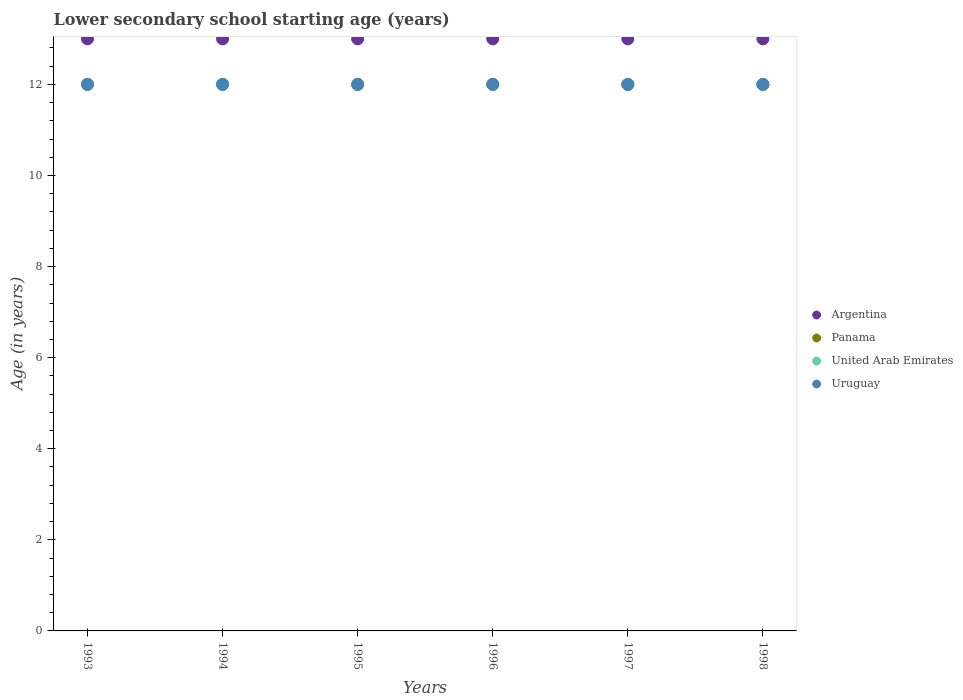Is the number of dotlines equal to the number of legend labels?
Your response must be concise. Yes. What is the lower secondary school starting age of children in Panama in 1996?
Ensure brevity in your answer.  12. Across all years, what is the maximum lower secondary school starting age of children in United Arab Emirates?
Offer a very short reply. 12. Across all years, what is the minimum lower secondary school starting age of children in Uruguay?
Keep it short and to the point. 12. In which year was the lower secondary school starting age of children in Argentina maximum?
Offer a very short reply. 1993. In which year was the lower secondary school starting age of children in Uruguay minimum?
Your answer should be compact. 1993. What is the total lower secondary school starting age of children in United Arab Emirates in the graph?
Give a very brief answer. 72. What is the difference between the lower secondary school starting age of children in Panama in 1994 and the lower secondary school starting age of children in United Arab Emirates in 1997?
Ensure brevity in your answer.  0. In the year 1996, what is the difference between the lower secondary school starting age of children in United Arab Emirates and lower secondary school starting age of children in Argentina?
Your answer should be compact. -1. In how many years, is the lower secondary school starting age of children in Argentina greater than 9.2 years?
Your answer should be compact. 6. Is the lower secondary school starting age of children in Argentina in 1994 less than that in 1998?
Your response must be concise. No. What is the difference between the highest and the second highest lower secondary school starting age of children in Argentina?
Provide a short and direct response. 0. Is it the case that in every year, the sum of the lower secondary school starting age of children in Argentina and lower secondary school starting age of children in Uruguay  is greater than the sum of lower secondary school starting age of children in United Arab Emirates and lower secondary school starting age of children in Panama?
Keep it short and to the point. No. Is it the case that in every year, the sum of the lower secondary school starting age of children in Panama and lower secondary school starting age of children in United Arab Emirates  is greater than the lower secondary school starting age of children in Argentina?
Provide a succinct answer. Yes. How many dotlines are there?
Keep it short and to the point. 4. How many years are there in the graph?
Keep it short and to the point. 6. What is the difference between two consecutive major ticks on the Y-axis?
Offer a terse response. 2. Are the values on the major ticks of Y-axis written in scientific E-notation?
Give a very brief answer. No. Where does the legend appear in the graph?
Provide a short and direct response. Center right. How are the legend labels stacked?
Offer a very short reply. Vertical. What is the title of the graph?
Keep it short and to the point. Lower secondary school starting age (years). Does "Middle East & North Africa (developing only)" appear as one of the legend labels in the graph?
Keep it short and to the point. No. What is the label or title of the X-axis?
Provide a short and direct response. Years. What is the label or title of the Y-axis?
Offer a terse response. Age (in years). What is the Age (in years) of United Arab Emirates in 1993?
Give a very brief answer. 12. What is the Age (in years) of Uruguay in 1993?
Provide a short and direct response. 12. What is the Age (in years) of Argentina in 1994?
Provide a succinct answer. 13. What is the Age (in years) in United Arab Emirates in 1994?
Your response must be concise. 12. What is the Age (in years) of Argentina in 1995?
Your answer should be very brief. 13. What is the Age (in years) of Panama in 1995?
Make the answer very short. 12. What is the Age (in years) of United Arab Emirates in 1995?
Your answer should be compact. 12. What is the Age (in years) in Argentina in 1996?
Offer a terse response. 13. What is the Age (in years) of Panama in 1996?
Your answer should be very brief. 12. What is the Age (in years) in United Arab Emirates in 1996?
Ensure brevity in your answer.  12. What is the Age (in years) in Uruguay in 1996?
Keep it short and to the point. 12. What is the Age (in years) of Argentina in 1998?
Your answer should be compact. 13. What is the Age (in years) in Uruguay in 1998?
Keep it short and to the point. 12. Across all years, what is the maximum Age (in years) in Argentina?
Your answer should be very brief. 13. Across all years, what is the maximum Age (in years) in Uruguay?
Your answer should be compact. 12. Across all years, what is the minimum Age (in years) of Panama?
Ensure brevity in your answer.  12. Across all years, what is the minimum Age (in years) of United Arab Emirates?
Provide a short and direct response. 12. What is the total Age (in years) of Argentina in the graph?
Make the answer very short. 78. What is the total Age (in years) in Panama in the graph?
Provide a succinct answer. 72. What is the difference between the Age (in years) of Argentina in 1993 and that in 1994?
Provide a short and direct response. 0. What is the difference between the Age (in years) of United Arab Emirates in 1993 and that in 1994?
Keep it short and to the point. 0. What is the difference between the Age (in years) in Uruguay in 1993 and that in 1995?
Your answer should be very brief. 0. What is the difference between the Age (in years) in United Arab Emirates in 1993 and that in 1996?
Make the answer very short. 0. What is the difference between the Age (in years) in United Arab Emirates in 1993 and that in 1997?
Offer a very short reply. 0. What is the difference between the Age (in years) of Uruguay in 1993 and that in 1997?
Keep it short and to the point. 0. What is the difference between the Age (in years) in Argentina in 1993 and that in 1998?
Give a very brief answer. 0. What is the difference between the Age (in years) in Panama in 1993 and that in 1998?
Make the answer very short. 0. What is the difference between the Age (in years) of United Arab Emirates in 1993 and that in 1998?
Your answer should be very brief. 0. What is the difference between the Age (in years) in Uruguay in 1993 and that in 1998?
Offer a very short reply. 0. What is the difference between the Age (in years) of Argentina in 1994 and that in 1995?
Offer a terse response. 0. What is the difference between the Age (in years) of United Arab Emirates in 1994 and that in 1995?
Your answer should be compact. 0. What is the difference between the Age (in years) of Panama in 1994 and that in 1996?
Give a very brief answer. 0. What is the difference between the Age (in years) of United Arab Emirates in 1994 and that in 1997?
Give a very brief answer. 0. What is the difference between the Age (in years) of Panama in 1994 and that in 1998?
Give a very brief answer. 0. What is the difference between the Age (in years) in Argentina in 1995 and that in 1996?
Keep it short and to the point. 0. What is the difference between the Age (in years) of Panama in 1995 and that in 1996?
Offer a terse response. 0. What is the difference between the Age (in years) in United Arab Emirates in 1995 and that in 1996?
Provide a short and direct response. 0. What is the difference between the Age (in years) of Argentina in 1995 and that in 1997?
Your response must be concise. 0. What is the difference between the Age (in years) of Panama in 1995 and that in 1997?
Provide a succinct answer. 0. What is the difference between the Age (in years) of United Arab Emirates in 1995 and that in 1997?
Your response must be concise. 0. What is the difference between the Age (in years) in Uruguay in 1995 and that in 1997?
Offer a very short reply. 0. What is the difference between the Age (in years) of United Arab Emirates in 1996 and that in 1997?
Ensure brevity in your answer.  0. What is the difference between the Age (in years) of Argentina in 1997 and that in 1998?
Provide a succinct answer. 0. What is the difference between the Age (in years) of Panama in 1997 and that in 1998?
Offer a very short reply. 0. What is the difference between the Age (in years) in Uruguay in 1997 and that in 1998?
Make the answer very short. 0. What is the difference between the Age (in years) in Argentina in 1993 and the Age (in years) in Uruguay in 1994?
Offer a very short reply. 1. What is the difference between the Age (in years) of Panama in 1993 and the Age (in years) of Uruguay in 1994?
Offer a very short reply. 0. What is the difference between the Age (in years) in United Arab Emirates in 1993 and the Age (in years) in Uruguay in 1994?
Your response must be concise. 0. What is the difference between the Age (in years) of Argentina in 1993 and the Age (in years) of Uruguay in 1995?
Offer a very short reply. 1. What is the difference between the Age (in years) in Panama in 1993 and the Age (in years) in United Arab Emirates in 1995?
Your answer should be very brief. 0. What is the difference between the Age (in years) of Panama in 1993 and the Age (in years) of Uruguay in 1995?
Your response must be concise. 0. What is the difference between the Age (in years) in United Arab Emirates in 1993 and the Age (in years) in Uruguay in 1995?
Ensure brevity in your answer.  0. What is the difference between the Age (in years) in Argentina in 1993 and the Age (in years) in Panama in 1996?
Your response must be concise. 1. What is the difference between the Age (in years) in Panama in 1993 and the Age (in years) in United Arab Emirates in 1996?
Your response must be concise. 0. What is the difference between the Age (in years) of United Arab Emirates in 1993 and the Age (in years) of Uruguay in 1996?
Provide a short and direct response. 0. What is the difference between the Age (in years) in Argentina in 1993 and the Age (in years) in Panama in 1997?
Keep it short and to the point. 1. What is the difference between the Age (in years) in Argentina in 1993 and the Age (in years) in Uruguay in 1997?
Your response must be concise. 1. What is the difference between the Age (in years) in Panama in 1993 and the Age (in years) in United Arab Emirates in 1997?
Provide a short and direct response. 0. What is the difference between the Age (in years) of Panama in 1993 and the Age (in years) of Uruguay in 1997?
Give a very brief answer. 0. What is the difference between the Age (in years) in Argentina in 1993 and the Age (in years) in Panama in 1998?
Your response must be concise. 1. What is the difference between the Age (in years) in Argentina in 1993 and the Age (in years) in Uruguay in 1998?
Keep it short and to the point. 1. What is the difference between the Age (in years) of Panama in 1993 and the Age (in years) of United Arab Emirates in 1998?
Ensure brevity in your answer.  0. What is the difference between the Age (in years) in Panama in 1993 and the Age (in years) in Uruguay in 1998?
Your answer should be compact. 0. What is the difference between the Age (in years) of Argentina in 1994 and the Age (in years) of Panama in 1995?
Make the answer very short. 1. What is the difference between the Age (in years) in Argentina in 1994 and the Age (in years) in Uruguay in 1995?
Your answer should be compact. 1. What is the difference between the Age (in years) of Argentina in 1994 and the Age (in years) of United Arab Emirates in 1996?
Make the answer very short. 1. What is the difference between the Age (in years) of Argentina in 1994 and the Age (in years) of Uruguay in 1996?
Ensure brevity in your answer.  1. What is the difference between the Age (in years) in Argentina in 1994 and the Age (in years) in United Arab Emirates in 1997?
Your answer should be very brief. 1. What is the difference between the Age (in years) of Panama in 1994 and the Age (in years) of United Arab Emirates in 1997?
Offer a very short reply. 0. What is the difference between the Age (in years) in United Arab Emirates in 1994 and the Age (in years) in Uruguay in 1997?
Ensure brevity in your answer.  0. What is the difference between the Age (in years) in Argentina in 1994 and the Age (in years) in Panama in 1998?
Keep it short and to the point. 1. What is the difference between the Age (in years) in Argentina in 1994 and the Age (in years) in United Arab Emirates in 1998?
Ensure brevity in your answer.  1. What is the difference between the Age (in years) in Argentina in 1994 and the Age (in years) in Uruguay in 1998?
Your response must be concise. 1. What is the difference between the Age (in years) in Panama in 1994 and the Age (in years) in United Arab Emirates in 1998?
Provide a short and direct response. 0. What is the difference between the Age (in years) of Argentina in 1995 and the Age (in years) of Panama in 1996?
Offer a terse response. 1. What is the difference between the Age (in years) of Argentina in 1995 and the Age (in years) of United Arab Emirates in 1996?
Keep it short and to the point. 1. What is the difference between the Age (in years) in United Arab Emirates in 1995 and the Age (in years) in Uruguay in 1996?
Your answer should be very brief. 0. What is the difference between the Age (in years) of Argentina in 1995 and the Age (in years) of Uruguay in 1997?
Ensure brevity in your answer.  1. What is the difference between the Age (in years) in Panama in 1995 and the Age (in years) in Uruguay in 1997?
Your response must be concise. 0. What is the difference between the Age (in years) of Argentina in 1995 and the Age (in years) of Panama in 1998?
Make the answer very short. 1. What is the difference between the Age (in years) of Argentina in 1995 and the Age (in years) of United Arab Emirates in 1998?
Provide a short and direct response. 1. What is the difference between the Age (in years) of United Arab Emirates in 1995 and the Age (in years) of Uruguay in 1998?
Offer a very short reply. 0. What is the difference between the Age (in years) in Argentina in 1996 and the Age (in years) in Panama in 1997?
Offer a very short reply. 1. What is the difference between the Age (in years) of Argentina in 1996 and the Age (in years) of United Arab Emirates in 1997?
Provide a succinct answer. 1. What is the difference between the Age (in years) in Panama in 1996 and the Age (in years) in Uruguay in 1997?
Provide a succinct answer. 0. What is the difference between the Age (in years) in United Arab Emirates in 1996 and the Age (in years) in Uruguay in 1997?
Make the answer very short. 0. What is the difference between the Age (in years) of Panama in 1996 and the Age (in years) of United Arab Emirates in 1998?
Keep it short and to the point. 0. What is the difference between the Age (in years) of Panama in 1996 and the Age (in years) of Uruguay in 1998?
Ensure brevity in your answer.  0. What is the difference between the Age (in years) of United Arab Emirates in 1996 and the Age (in years) of Uruguay in 1998?
Your response must be concise. 0. What is the difference between the Age (in years) in Argentina in 1997 and the Age (in years) in Panama in 1998?
Give a very brief answer. 1. What is the difference between the Age (in years) in United Arab Emirates in 1997 and the Age (in years) in Uruguay in 1998?
Offer a terse response. 0. What is the average Age (in years) in Argentina per year?
Your answer should be compact. 13. What is the average Age (in years) of Panama per year?
Your response must be concise. 12. What is the average Age (in years) in United Arab Emirates per year?
Provide a short and direct response. 12. In the year 1993, what is the difference between the Age (in years) of Argentina and Age (in years) of Panama?
Give a very brief answer. 1. In the year 1994, what is the difference between the Age (in years) in Argentina and Age (in years) in United Arab Emirates?
Your answer should be very brief. 1. In the year 1994, what is the difference between the Age (in years) in Panama and Age (in years) in Uruguay?
Keep it short and to the point. 0. In the year 1994, what is the difference between the Age (in years) of United Arab Emirates and Age (in years) of Uruguay?
Your answer should be very brief. 0. In the year 1995, what is the difference between the Age (in years) of Argentina and Age (in years) of Panama?
Keep it short and to the point. 1. In the year 1995, what is the difference between the Age (in years) in Argentina and Age (in years) in Uruguay?
Provide a short and direct response. 1. In the year 1995, what is the difference between the Age (in years) in Panama and Age (in years) in United Arab Emirates?
Your answer should be very brief. 0. In the year 1996, what is the difference between the Age (in years) of Argentina and Age (in years) of Panama?
Provide a short and direct response. 1. In the year 1996, what is the difference between the Age (in years) of Panama and Age (in years) of United Arab Emirates?
Offer a very short reply. 0. In the year 1996, what is the difference between the Age (in years) in United Arab Emirates and Age (in years) in Uruguay?
Ensure brevity in your answer.  0. In the year 1997, what is the difference between the Age (in years) in Argentina and Age (in years) in United Arab Emirates?
Your answer should be very brief. 1. In the year 1998, what is the difference between the Age (in years) of Argentina and Age (in years) of United Arab Emirates?
Your answer should be very brief. 1. In the year 1998, what is the difference between the Age (in years) of Argentina and Age (in years) of Uruguay?
Ensure brevity in your answer.  1. In the year 1998, what is the difference between the Age (in years) of Panama and Age (in years) of United Arab Emirates?
Provide a succinct answer. 0. In the year 1998, what is the difference between the Age (in years) in Panama and Age (in years) in Uruguay?
Provide a succinct answer. 0. In the year 1998, what is the difference between the Age (in years) in United Arab Emirates and Age (in years) in Uruguay?
Ensure brevity in your answer.  0. What is the ratio of the Age (in years) of Argentina in 1993 to that in 1994?
Make the answer very short. 1. What is the ratio of the Age (in years) of United Arab Emirates in 1993 to that in 1994?
Offer a very short reply. 1. What is the ratio of the Age (in years) in Uruguay in 1993 to that in 1995?
Offer a terse response. 1. What is the ratio of the Age (in years) in Panama in 1993 to that in 1996?
Your answer should be compact. 1. What is the ratio of the Age (in years) of United Arab Emirates in 1993 to that in 1996?
Make the answer very short. 1. What is the ratio of the Age (in years) in Uruguay in 1993 to that in 1996?
Provide a short and direct response. 1. What is the ratio of the Age (in years) of United Arab Emirates in 1993 to that in 1997?
Provide a short and direct response. 1. What is the ratio of the Age (in years) of Uruguay in 1993 to that in 1997?
Give a very brief answer. 1. What is the ratio of the Age (in years) in Argentina in 1993 to that in 1998?
Provide a short and direct response. 1. What is the ratio of the Age (in years) of Panama in 1993 to that in 1998?
Offer a terse response. 1. What is the ratio of the Age (in years) in Argentina in 1994 to that in 1995?
Offer a very short reply. 1. What is the ratio of the Age (in years) in United Arab Emirates in 1994 to that in 1995?
Provide a short and direct response. 1. What is the ratio of the Age (in years) of Uruguay in 1994 to that in 1995?
Provide a succinct answer. 1. What is the ratio of the Age (in years) of Argentina in 1994 to that in 1996?
Your answer should be very brief. 1. What is the ratio of the Age (in years) of United Arab Emirates in 1994 to that in 1996?
Ensure brevity in your answer.  1. What is the ratio of the Age (in years) of Uruguay in 1994 to that in 1996?
Your answer should be very brief. 1. What is the ratio of the Age (in years) in Argentina in 1994 to that in 1997?
Your answer should be very brief. 1. What is the ratio of the Age (in years) in Panama in 1994 to that in 1998?
Make the answer very short. 1. What is the ratio of the Age (in years) in Uruguay in 1994 to that in 1998?
Provide a short and direct response. 1. What is the ratio of the Age (in years) in Argentina in 1995 to that in 1996?
Your response must be concise. 1. What is the ratio of the Age (in years) of Argentina in 1995 to that in 1997?
Keep it short and to the point. 1. What is the ratio of the Age (in years) in Argentina in 1995 to that in 1998?
Your answer should be very brief. 1. What is the ratio of the Age (in years) in Panama in 1995 to that in 1998?
Give a very brief answer. 1. What is the ratio of the Age (in years) of United Arab Emirates in 1995 to that in 1998?
Provide a short and direct response. 1. What is the ratio of the Age (in years) of United Arab Emirates in 1996 to that in 1997?
Your answer should be very brief. 1. What is the ratio of the Age (in years) of United Arab Emirates in 1997 to that in 1998?
Give a very brief answer. 1. What is the ratio of the Age (in years) of Uruguay in 1997 to that in 1998?
Offer a very short reply. 1. What is the difference between the highest and the second highest Age (in years) in Argentina?
Offer a very short reply. 0. What is the difference between the highest and the second highest Age (in years) of Panama?
Your answer should be compact. 0. What is the difference between the highest and the second highest Age (in years) in Uruguay?
Offer a very short reply. 0. What is the difference between the highest and the lowest Age (in years) of Panama?
Your answer should be very brief. 0. What is the difference between the highest and the lowest Age (in years) in United Arab Emirates?
Give a very brief answer. 0. What is the difference between the highest and the lowest Age (in years) of Uruguay?
Your answer should be compact. 0. 